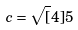Convert formula to latex. <formula><loc_0><loc_0><loc_500><loc_500>c = \sqrt { [ } 4 ] { 5 }</formula> 